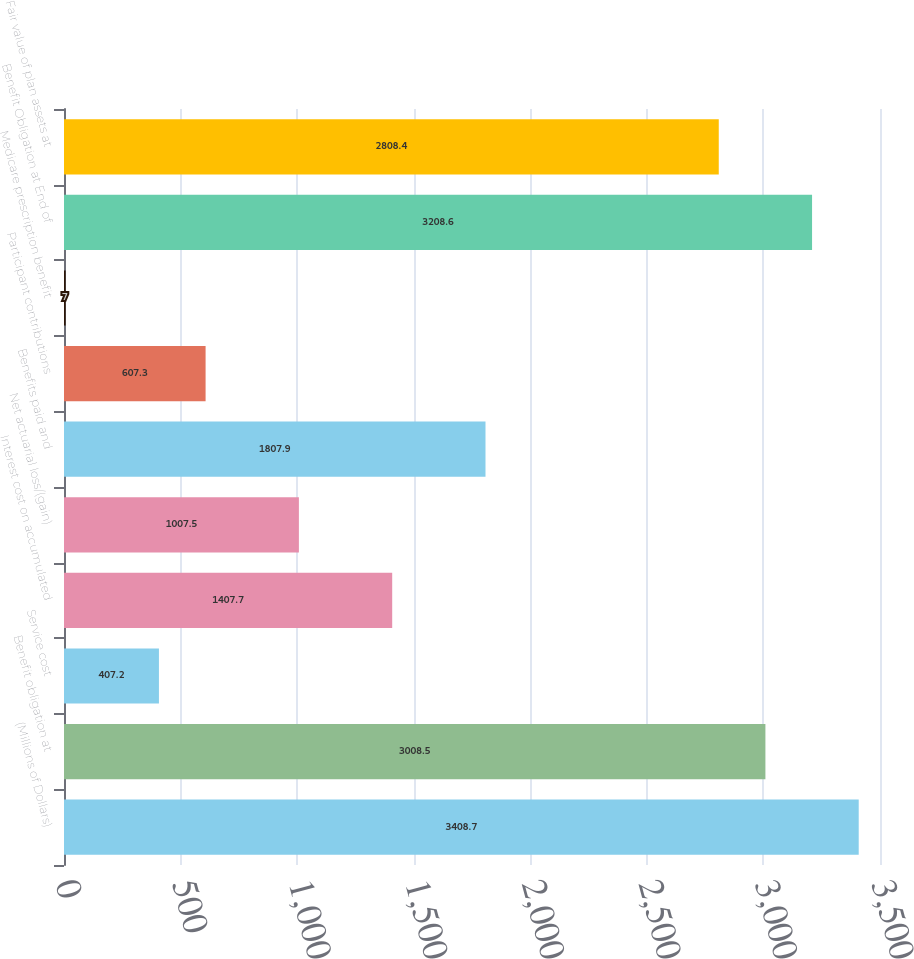Convert chart to OTSL. <chart><loc_0><loc_0><loc_500><loc_500><bar_chart><fcel>(Millions of Dollars)<fcel>Benefit obligation at<fcel>Service cost<fcel>Interest cost on accumulated<fcel>Net actuarial loss/(gain)<fcel>Benefits paid and<fcel>Participant contributions<fcel>Medicare prescription benefit<fcel>Benefit Obligation at End of<fcel>Fair value of plan assets at<nl><fcel>3408.7<fcel>3008.5<fcel>407.2<fcel>1407.7<fcel>1007.5<fcel>1807.9<fcel>607.3<fcel>7<fcel>3208.6<fcel>2808.4<nl></chart> 